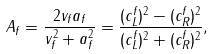<formula> <loc_0><loc_0><loc_500><loc_500>A _ { f } = \frac { 2 v _ { f } a _ { f } } { v _ { f } ^ { 2 } + a _ { f } ^ { 2 } } = \frac { ( c _ { L } ^ { f } ) ^ { 2 } - ( c _ { R } ^ { f } ) ^ { 2 } } { ( c _ { L } ^ { f } ) ^ { 2 } + ( c _ { R } ^ { f } ) ^ { 2 } } ,</formula> 